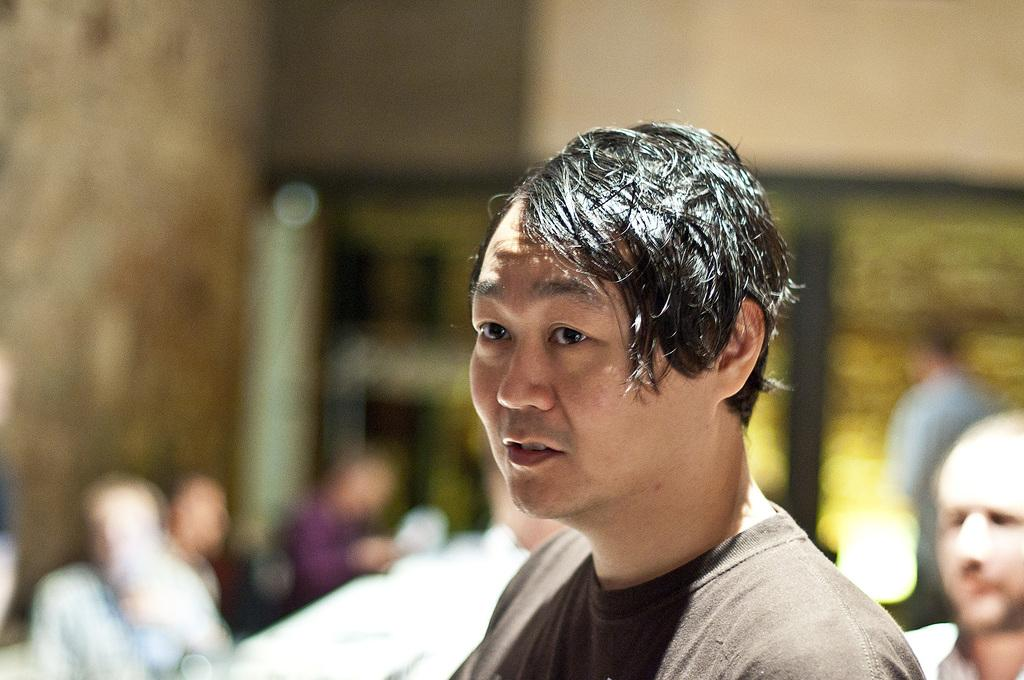Who is the main subject in the image? There is a man in the image. What can be seen in the background of the image? There are many people in the background of the image. How would you describe the appearance of the background? The background appears blurry. What type of bomb can be seen in the image? There is no bomb present in the image. What color is the chicken in the image? There is no chicken present in the image. 